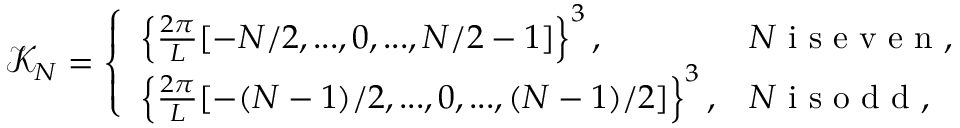Convert formula to latex. <formula><loc_0><loc_0><loc_500><loc_500>\mathcal { K } _ { N } = \left \{ \begin{array} { l l } { \left \{ \frac { 2 \pi } { L } [ - N / 2 , \dots , 0 , \dots , N / 2 - 1 ] \right \} ^ { 3 } , } & { N i s e v e n , } \\ { \left \{ \frac { 2 \pi } { L } [ - ( N - 1 ) / 2 , \dots , 0 , \dots , ( N - 1 ) / 2 ] \right \} ^ { 3 } , } & { N i s o d d , } \end{array}</formula> 